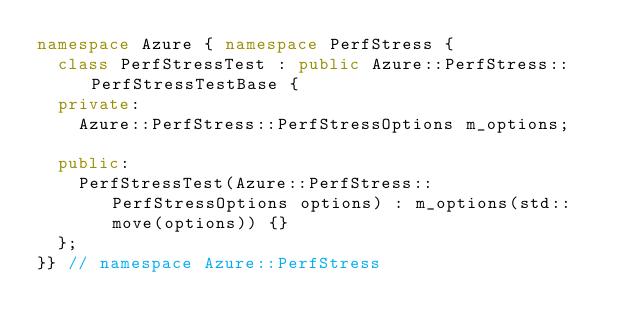<code> <loc_0><loc_0><loc_500><loc_500><_C++_>namespace Azure { namespace PerfStress {
  class PerfStressTest : public Azure::PerfStress::PerfStressTestBase {
  private:
    Azure::PerfStress::PerfStressOptions m_options;

  public:
    PerfStressTest(Azure::PerfStress::PerfStressOptions options) : m_options(std::move(options)) {}
  };
}} // namespace Azure::PerfStress
</code> 